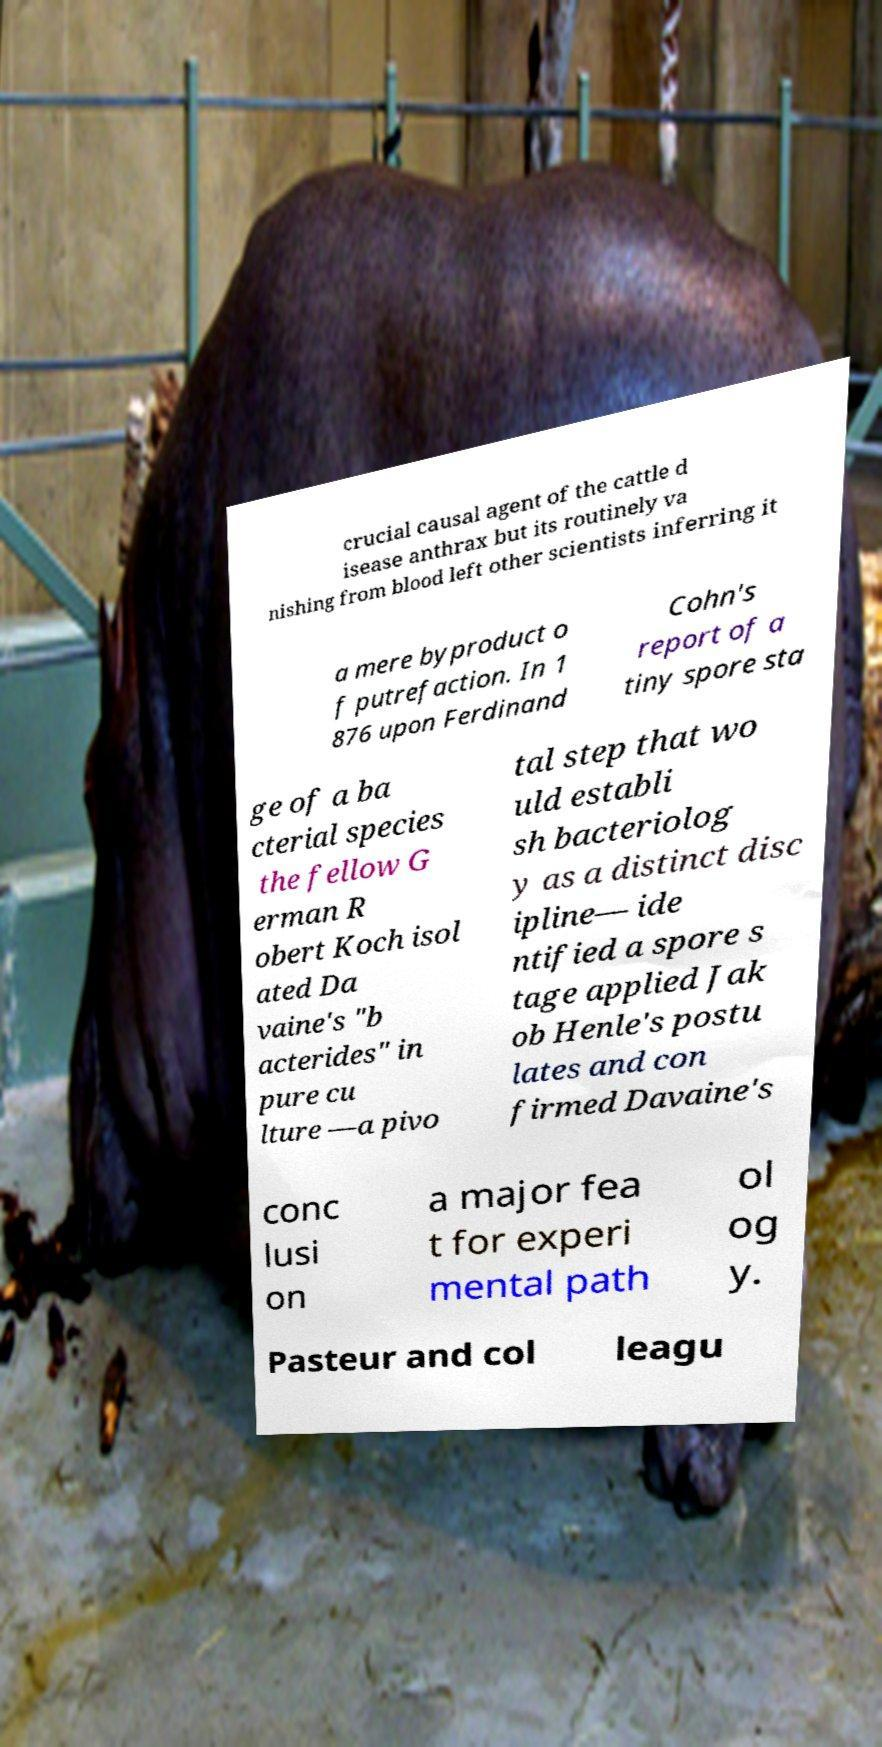For documentation purposes, I need the text within this image transcribed. Could you provide that? crucial causal agent of the cattle d isease anthrax but its routinely va nishing from blood left other scientists inferring it a mere byproduct o f putrefaction. In 1 876 upon Ferdinand Cohn's report of a tiny spore sta ge of a ba cterial species the fellow G erman R obert Koch isol ated Da vaine's "b acterides" in pure cu lture —a pivo tal step that wo uld establi sh bacteriolog y as a distinct disc ipline— ide ntified a spore s tage applied Jak ob Henle's postu lates and con firmed Davaine's conc lusi on a major fea t for experi mental path ol og y. Pasteur and col leagu 